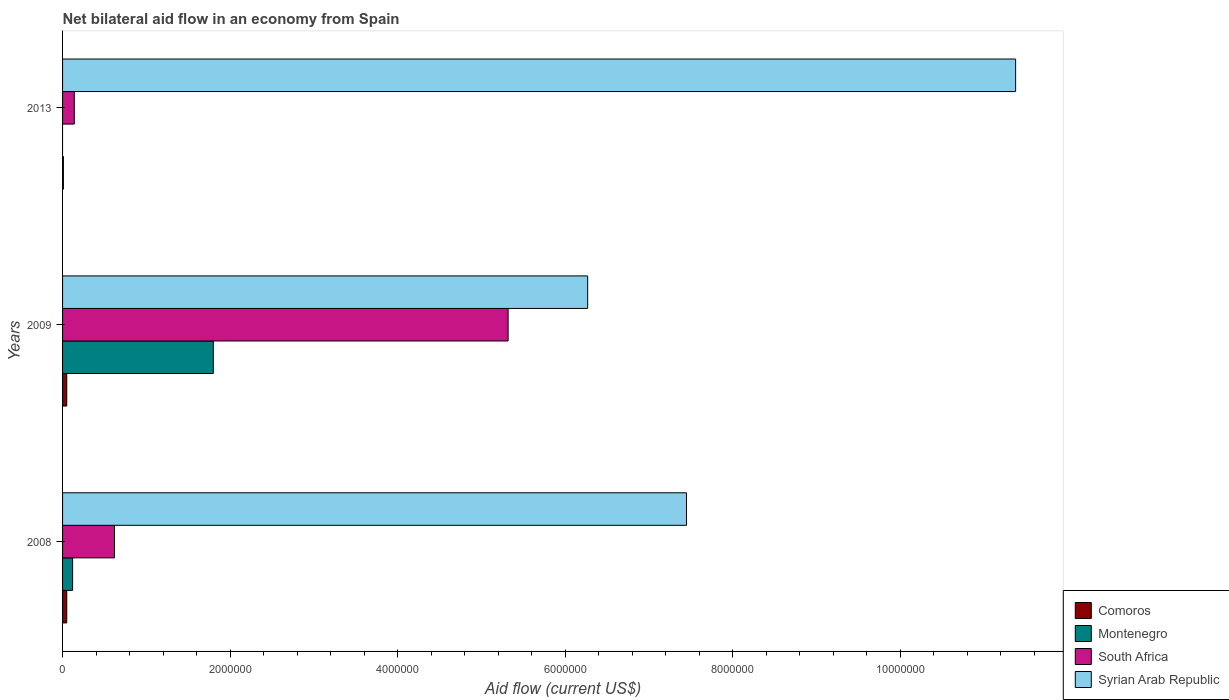How many different coloured bars are there?
Your response must be concise. 4. How many bars are there on the 1st tick from the bottom?
Give a very brief answer. 4. What is the label of the 2nd group of bars from the top?
Your answer should be compact. 2009. What is the net bilateral aid flow in Syrian Arab Republic in 2013?
Ensure brevity in your answer.  1.14e+07. Across all years, what is the maximum net bilateral aid flow in Comoros?
Ensure brevity in your answer.  5.00e+04. What is the total net bilateral aid flow in Syrian Arab Republic in the graph?
Give a very brief answer. 2.51e+07. What is the difference between the net bilateral aid flow in South Africa in 2009 and that in 2013?
Ensure brevity in your answer.  5.18e+06. What is the average net bilateral aid flow in Montenegro per year?
Your answer should be very brief. 6.40e+05. In the year 2008, what is the difference between the net bilateral aid flow in Comoros and net bilateral aid flow in South Africa?
Your answer should be very brief. -5.70e+05. In how many years, is the net bilateral aid flow in Comoros greater than 8000000 US$?
Make the answer very short. 0. What is the ratio of the net bilateral aid flow in Comoros in 2008 to that in 2013?
Offer a terse response. 5. Is the net bilateral aid flow in Syrian Arab Republic in 2009 less than that in 2013?
Keep it short and to the point. Yes. What is the difference between the highest and the second highest net bilateral aid flow in Syrian Arab Republic?
Offer a terse response. 3.93e+06. What is the difference between the highest and the lowest net bilateral aid flow in South Africa?
Your answer should be compact. 5.18e+06. In how many years, is the net bilateral aid flow in Syrian Arab Republic greater than the average net bilateral aid flow in Syrian Arab Republic taken over all years?
Your answer should be very brief. 1. Is it the case that in every year, the sum of the net bilateral aid flow in Syrian Arab Republic and net bilateral aid flow in South Africa is greater than the net bilateral aid flow in Montenegro?
Ensure brevity in your answer.  Yes. How many years are there in the graph?
Keep it short and to the point. 3. Does the graph contain any zero values?
Offer a terse response. Yes. Does the graph contain grids?
Your response must be concise. No. How are the legend labels stacked?
Keep it short and to the point. Vertical. What is the title of the graph?
Offer a very short reply. Net bilateral aid flow in an economy from Spain. What is the Aid flow (current US$) in Comoros in 2008?
Give a very brief answer. 5.00e+04. What is the Aid flow (current US$) in Montenegro in 2008?
Provide a short and direct response. 1.20e+05. What is the Aid flow (current US$) in South Africa in 2008?
Your response must be concise. 6.20e+05. What is the Aid flow (current US$) in Syrian Arab Republic in 2008?
Provide a short and direct response. 7.45e+06. What is the Aid flow (current US$) in Comoros in 2009?
Your response must be concise. 5.00e+04. What is the Aid flow (current US$) in Montenegro in 2009?
Provide a short and direct response. 1.80e+06. What is the Aid flow (current US$) in South Africa in 2009?
Your answer should be very brief. 5.32e+06. What is the Aid flow (current US$) in Syrian Arab Republic in 2009?
Offer a terse response. 6.27e+06. What is the Aid flow (current US$) in Comoros in 2013?
Make the answer very short. 10000. What is the Aid flow (current US$) in South Africa in 2013?
Offer a very short reply. 1.40e+05. What is the Aid flow (current US$) in Syrian Arab Republic in 2013?
Your answer should be very brief. 1.14e+07. Across all years, what is the maximum Aid flow (current US$) of Montenegro?
Provide a succinct answer. 1.80e+06. Across all years, what is the maximum Aid flow (current US$) of South Africa?
Provide a succinct answer. 5.32e+06. Across all years, what is the maximum Aid flow (current US$) of Syrian Arab Republic?
Your answer should be very brief. 1.14e+07. Across all years, what is the minimum Aid flow (current US$) in Comoros?
Give a very brief answer. 10000. Across all years, what is the minimum Aid flow (current US$) in South Africa?
Your answer should be compact. 1.40e+05. Across all years, what is the minimum Aid flow (current US$) in Syrian Arab Republic?
Your response must be concise. 6.27e+06. What is the total Aid flow (current US$) in Montenegro in the graph?
Make the answer very short. 1.92e+06. What is the total Aid flow (current US$) of South Africa in the graph?
Ensure brevity in your answer.  6.08e+06. What is the total Aid flow (current US$) of Syrian Arab Republic in the graph?
Your response must be concise. 2.51e+07. What is the difference between the Aid flow (current US$) of Comoros in 2008 and that in 2009?
Provide a succinct answer. 0. What is the difference between the Aid flow (current US$) of Montenegro in 2008 and that in 2009?
Provide a succinct answer. -1.68e+06. What is the difference between the Aid flow (current US$) in South Africa in 2008 and that in 2009?
Your response must be concise. -4.70e+06. What is the difference between the Aid flow (current US$) in Syrian Arab Republic in 2008 and that in 2009?
Offer a very short reply. 1.18e+06. What is the difference between the Aid flow (current US$) of Comoros in 2008 and that in 2013?
Give a very brief answer. 4.00e+04. What is the difference between the Aid flow (current US$) of Syrian Arab Republic in 2008 and that in 2013?
Your response must be concise. -3.93e+06. What is the difference between the Aid flow (current US$) in South Africa in 2009 and that in 2013?
Provide a succinct answer. 5.18e+06. What is the difference between the Aid flow (current US$) in Syrian Arab Republic in 2009 and that in 2013?
Ensure brevity in your answer.  -5.11e+06. What is the difference between the Aid flow (current US$) of Comoros in 2008 and the Aid flow (current US$) of Montenegro in 2009?
Make the answer very short. -1.75e+06. What is the difference between the Aid flow (current US$) in Comoros in 2008 and the Aid flow (current US$) in South Africa in 2009?
Offer a terse response. -5.27e+06. What is the difference between the Aid flow (current US$) in Comoros in 2008 and the Aid flow (current US$) in Syrian Arab Republic in 2009?
Make the answer very short. -6.22e+06. What is the difference between the Aid flow (current US$) of Montenegro in 2008 and the Aid flow (current US$) of South Africa in 2009?
Keep it short and to the point. -5.20e+06. What is the difference between the Aid flow (current US$) in Montenegro in 2008 and the Aid flow (current US$) in Syrian Arab Republic in 2009?
Provide a succinct answer. -6.15e+06. What is the difference between the Aid flow (current US$) of South Africa in 2008 and the Aid flow (current US$) of Syrian Arab Republic in 2009?
Provide a succinct answer. -5.65e+06. What is the difference between the Aid flow (current US$) in Comoros in 2008 and the Aid flow (current US$) in Syrian Arab Republic in 2013?
Give a very brief answer. -1.13e+07. What is the difference between the Aid flow (current US$) in Montenegro in 2008 and the Aid flow (current US$) in Syrian Arab Republic in 2013?
Your answer should be very brief. -1.13e+07. What is the difference between the Aid flow (current US$) in South Africa in 2008 and the Aid flow (current US$) in Syrian Arab Republic in 2013?
Give a very brief answer. -1.08e+07. What is the difference between the Aid flow (current US$) in Comoros in 2009 and the Aid flow (current US$) in South Africa in 2013?
Your answer should be very brief. -9.00e+04. What is the difference between the Aid flow (current US$) of Comoros in 2009 and the Aid flow (current US$) of Syrian Arab Republic in 2013?
Your response must be concise. -1.13e+07. What is the difference between the Aid flow (current US$) of Montenegro in 2009 and the Aid flow (current US$) of South Africa in 2013?
Your answer should be very brief. 1.66e+06. What is the difference between the Aid flow (current US$) in Montenegro in 2009 and the Aid flow (current US$) in Syrian Arab Republic in 2013?
Provide a succinct answer. -9.58e+06. What is the difference between the Aid flow (current US$) of South Africa in 2009 and the Aid flow (current US$) of Syrian Arab Republic in 2013?
Give a very brief answer. -6.06e+06. What is the average Aid flow (current US$) of Comoros per year?
Your answer should be compact. 3.67e+04. What is the average Aid flow (current US$) in Montenegro per year?
Your answer should be compact. 6.40e+05. What is the average Aid flow (current US$) of South Africa per year?
Give a very brief answer. 2.03e+06. What is the average Aid flow (current US$) in Syrian Arab Republic per year?
Keep it short and to the point. 8.37e+06. In the year 2008, what is the difference between the Aid flow (current US$) in Comoros and Aid flow (current US$) in South Africa?
Give a very brief answer. -5.70e+05. In the year 2008, what is the difference between the Aid flow (current US$) of Comoros and Aid flow (current US$) of Syrian Arab Republic?
Your answer should be compact. -7.40e+06. In the year 2008, what is the difference between the Aid flow (current US$) of Montenegro and Aid flow (current US$) of South Africa?
Offer a terse response. -5.00e+05. In the year 2008, what is the difference between the Aid flow (current US$) in Montenegro and Aid flow (current US$) in Syrian Arab Republic?
Offer a very short reply. -7.33e+06. In the year 2008, what is the difference between the Aid flow (current US$) in South Africa and Aid flow (current US$) in Syrian Arab Republic?
Your answer should be very brief. -6.83e+06. In the year 2009, what is the difference between the Aid flow (current US$) in Comoros and Aid flow (current US$) in Montenegro?
Your answer should be very brief. -1.75e+06. In the year 2009, what is the difference between the Aid flow (current US$) in Comoros and Aid flow (current US$) in South Africa?
Offer a terse response. -5.27e+06. In the year 2009, what is the difference between the Aid flow (current US$) of Comoros and Aid flow (current US$) of Syrian Arab Republic?
Give a very brief answer. -6.22e+06. In the year 2009, what is the difference between the Aid flow (current US$) of Montenegro and Aid flow (current US$) of South Africa?
Provide a short and direct response. -3.52e+06. In the year 2009, what is the difference between the Aid flow (current US$) of Montenegro and Aid flow (current US$) of Syrian Arab Republic?
Your answer should be very brief. -4.47e+06. In the year 2009, what is the difference between the Aid flow (current US$) of South Africa and Aid flow (current US$) of Syrian Arab Republic?
Offer a terse response. -9.50e+05. In the year 2013, what is the difference between the Aid flow (current US$) in Comoros and Aid flow (current US$) in Syrian Arab Republic?
Your answer should be compact. -1.14e+07. In the year 2013, what is the difference between the Aid flow (current US$) of South Africa and Aid flow (current US$) of Syrian Arab Republic?
Your answer should be compact. -1.12e+07. What is the ratio of the Aid flow (current US$) in Montenegro in 2008 to that in 2009?
Offer a terse response. 0.07. What is the ratio of the Aid flow (current US$) in South Africa in 2008 to that in 2009?
Offer a terse response. 0.12. What is the ratio of the Aid flow (current US$) of Syrian Arab Republic in 2008 to that in 2009?
Provide a short and direct response. 1.19. What is the ratio of the Aid flow (current US$) in South Africa in 2008 to that in 2013?
Offer a very short reply. 4.43. What is the ratio of the Aid flow (current US$) of Syrian Arab Republic in 2008 to that in 2013?
Ensure brevity in your answer.  0.65. What is the ratio of the Aid flow (current US$) in Comoros in 2009 to that in 2013?
Give a very brief answer. 5. What is the ratio of the Aid flow (current US$) in South Africa in 2009 to that in 2013?
Provide a succinct answer. 38. What is the ratio of the Aid flow (current US$) in Syrian Arab Republic in 2009 to that in 2013?
Ensure brevity in your answer.  0.55. What is the difference between the highest and the second highest Aid flow (current US$) of Comoros?
Your response must be concise. 0. What is the difference between the highest and the second highest Aid flow (current US$) in South Africa?
Ensure brevity in your answer.  4.70e+06. What is the difference between the highest and the second highest Aid flow (current US$) of Syrian Arab Republic?
Offer a terse response. 3.93e+06. What is the difference between the highest and the lowest Aid flow (current US$) of Comoros?
Your answer should be very brief. 4.00e+04. What is the difference between the highest and the lowest Aid flow (current US$) of Montenegro?
Offer a very short reply. 1.80e+06. What is the difference between the highest and the lowest Aid flow (current US$) of South Africa?
Keep it short and to the point. 5.18e+06. What is the difference between the highest and the lowest Aid flow (current US$) in Syrian Arab Republic?
Offer a terse response. 5.11e+06. 